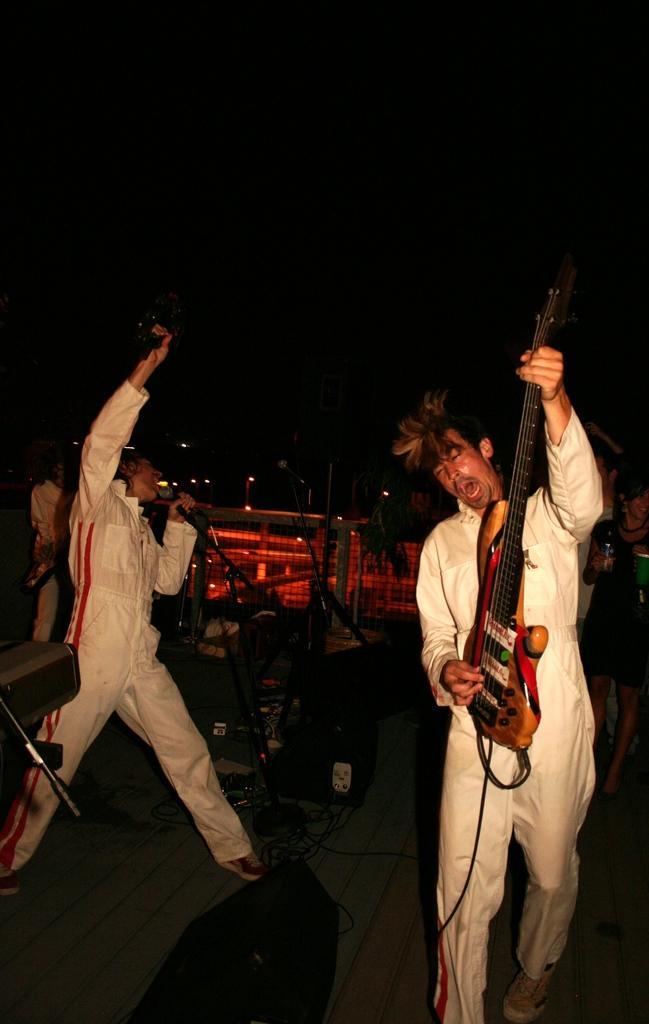Please provide a concise description of this image. There are two people in the picture and the one is holding the mike and raising his right hand and the other guy his holding a musical instrument playing it. They are in the same color dress. 